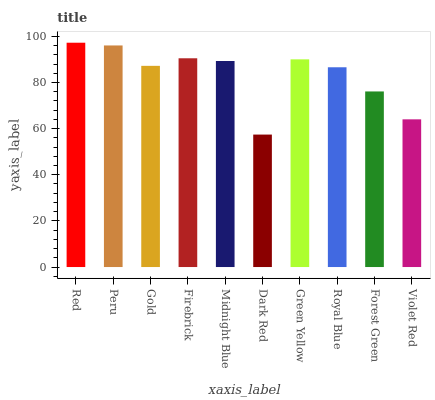Is Peru the minimum?
Answer yes or no. No. Is Peru the maximum?
Answer yes or no. No. Is Red greater than Peru?
Answer yes or no. Yes. Is Peru less than Red?
Answer yes or no. Yes. Is Peru greater than Red?
Answer yes or no. No. Is Red less than Peru?
Answer yes or no. No. Is Midnight Blue the high median?
Answer yes or no. Yes. Is Gold the low median?
Answer yes or no. Yes. Is Green Yellow the high median?
Answer yes or no. No. Is Violet Red the low median?
Answer yes or no. No. 